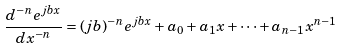Convert formula to latex. <formula><loc_0><loc_0><loc_500><loc_500>\frac { d ^ { - n } e ^ { j b x } } { d x ^ { - n } } = ( j b ) ^ { - n } e ^ { j b x } + a _ { 0 } + a _ { 1 } x + \cdot \cdot \cdot + a _ { n - 1 } x ^ { n - 1 }</formula> 